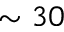<formula> <loc_0><loc_0><loc_500><loc_500>\sim 3 0</formula> 